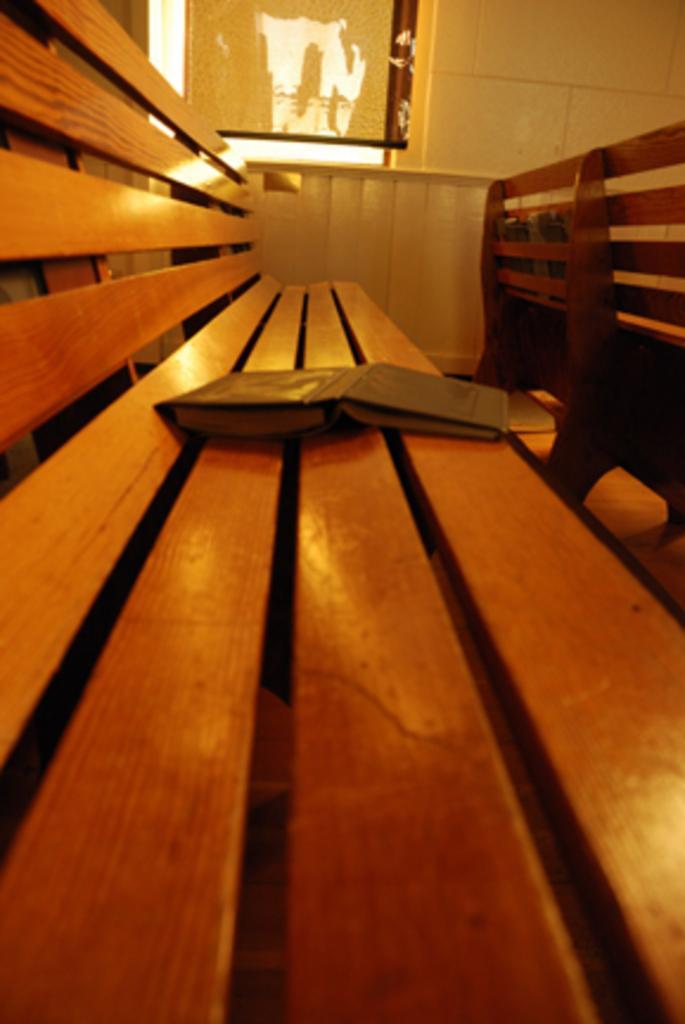Describe this image in one or two sentences. This is a book, which is placed on a wooden bench. I think this is a window. Here is the wall. On the right side of the image, I can see another bench. 